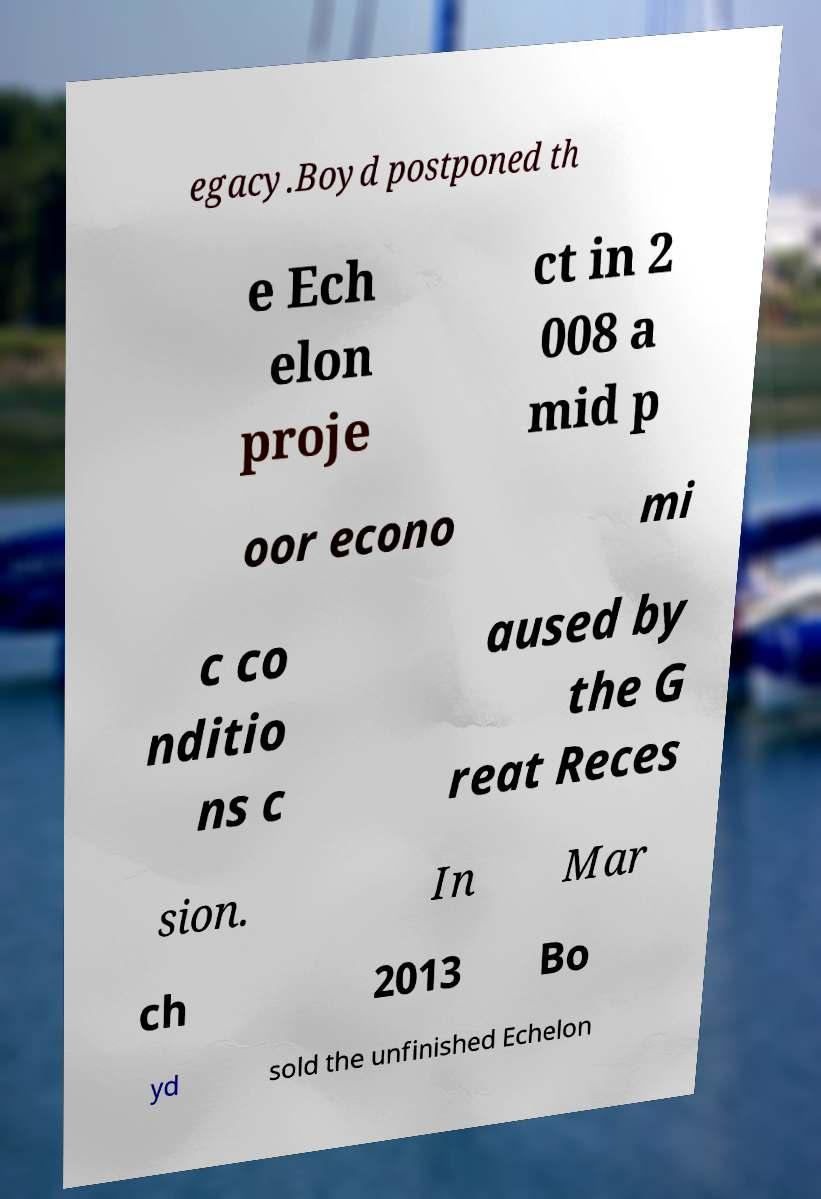For documentation purposes, I need the text within this image transcribed. Could you provide that? egacy.Boyd postponed th e Ech elon proje ct in 2 008 a mid p oor econo mi c co nditio ns c aused by the G reat Reces sion. In Mar ch 2013 Bo yd sold the unfinished Echelon 